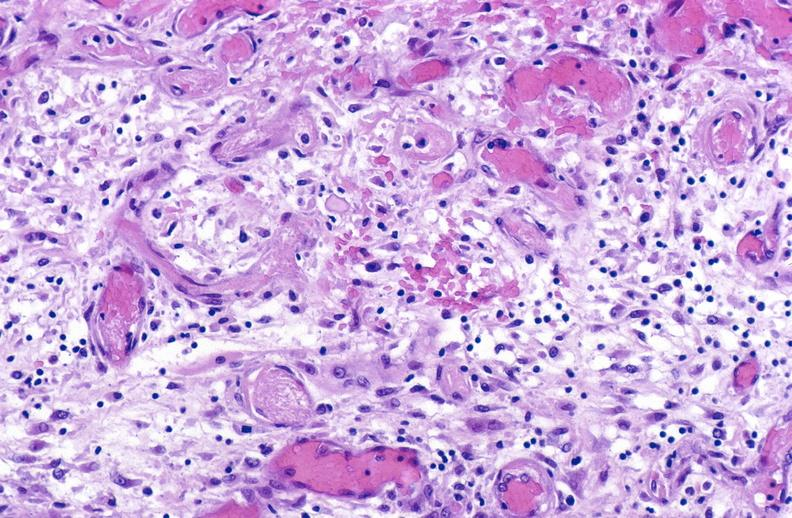s carcinomatosis present?
Answer the question using a single word or phrase. No 